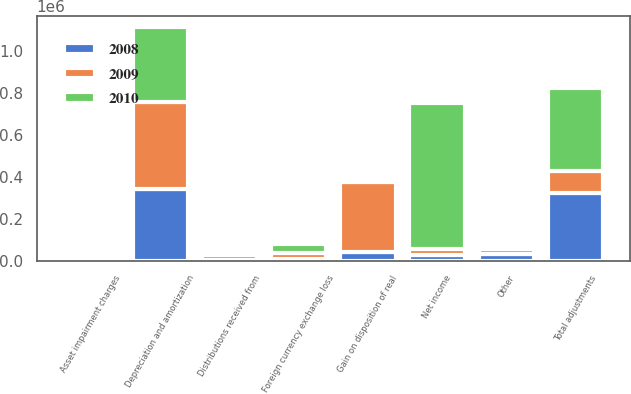Convert chart. <chart><loc_0><loc_0><loc_500><loc_500><stacked_bar_chart><ecel><fcel>Net income<fcel>Gain on disposition of real<fcel>Asset impairment charges<fcel>Depreciation and amortization<fcel>Distributions received from<fcel>Foreign currency exchange loss<fcel>Other<fcel>Total adjustments<nl><fcel>2010<fcel>696114<fcel>8190<fcel>2927<fcel>354386<fcel>11536<fcel>42264<fcel>5385<fcel>397107<nl><fcel>2008<fcel>27243.5<fcel>39444<fcel>8205<fcel>342127<fcel>3836<fcel>9662<fcel>29125<fcel>322401<nl><fcel>2009<fcel>27243.5<fcel>336545<fcel>525<fcel>414201<fcel>23064<fcel>25362<fcel>23508<fcel>103099<nl></chart> 